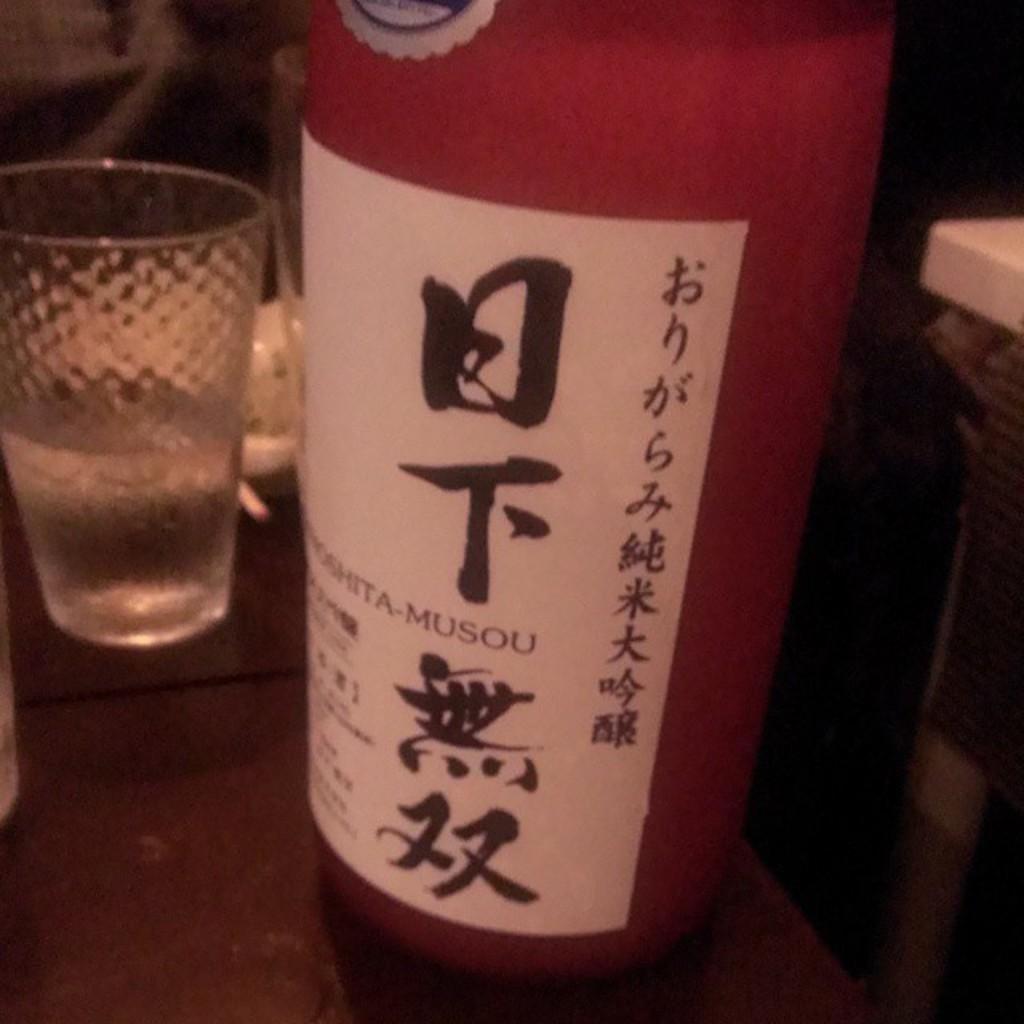Can you describe this image briefly? In the foreground of this we can see an object seems to be the bottle and we can see the text on the paper attached to the bottle and we can see the glass and some other objects. 